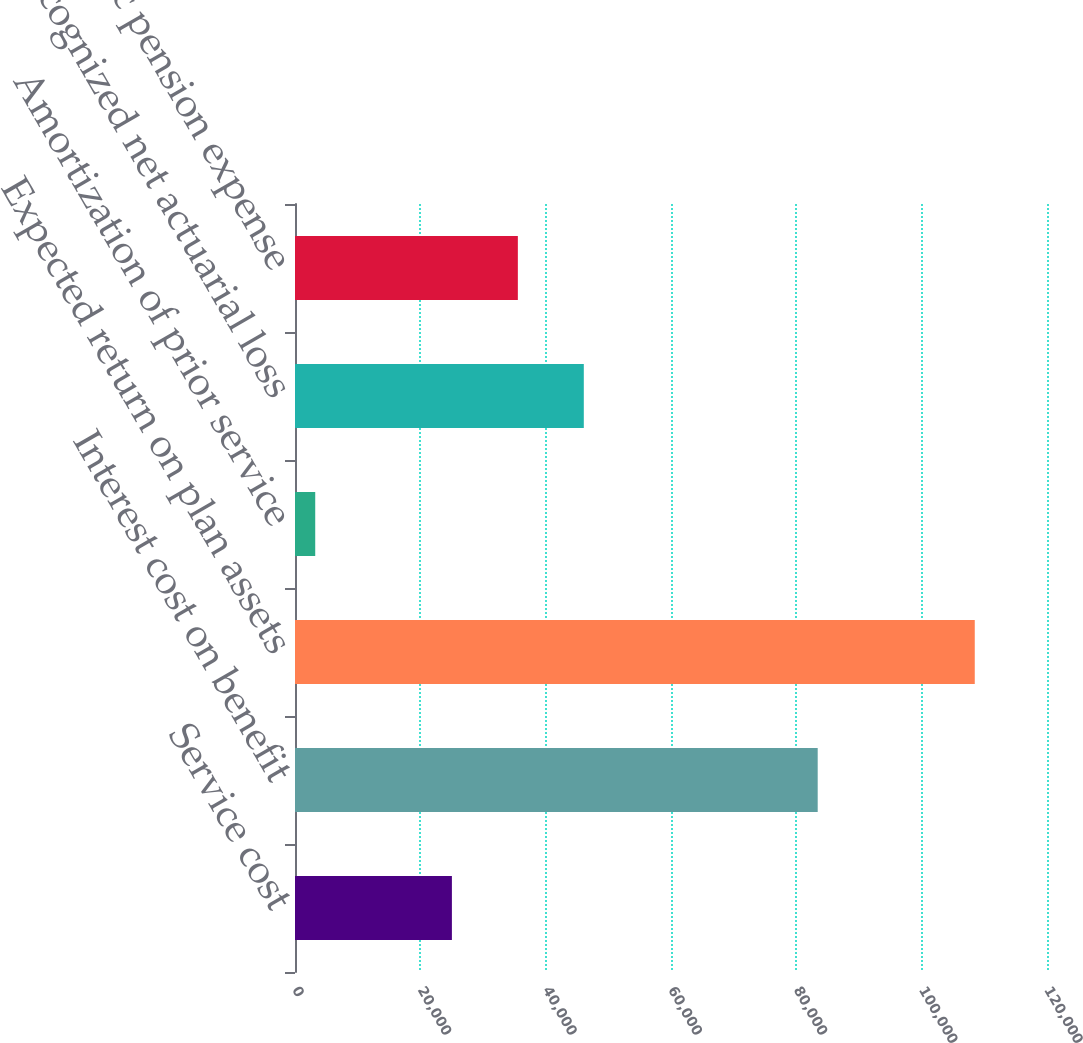Convert chart to OTSL. <chart><loc_0><loc_0><loc_500><loc_500><bar_chart><fcel>Service cost<fcel>Interest cost on benefit<fcel>Expected return on plan assets<fcel>Amortization of prior service<fcel>Recognized net actuarial loss<fcel>Net periodic pension expense<nl><fcel>25037<fcel>83410<fcel>108473<fcel>3228<fcel>46086<fcel>35561.5<nl></chart> 